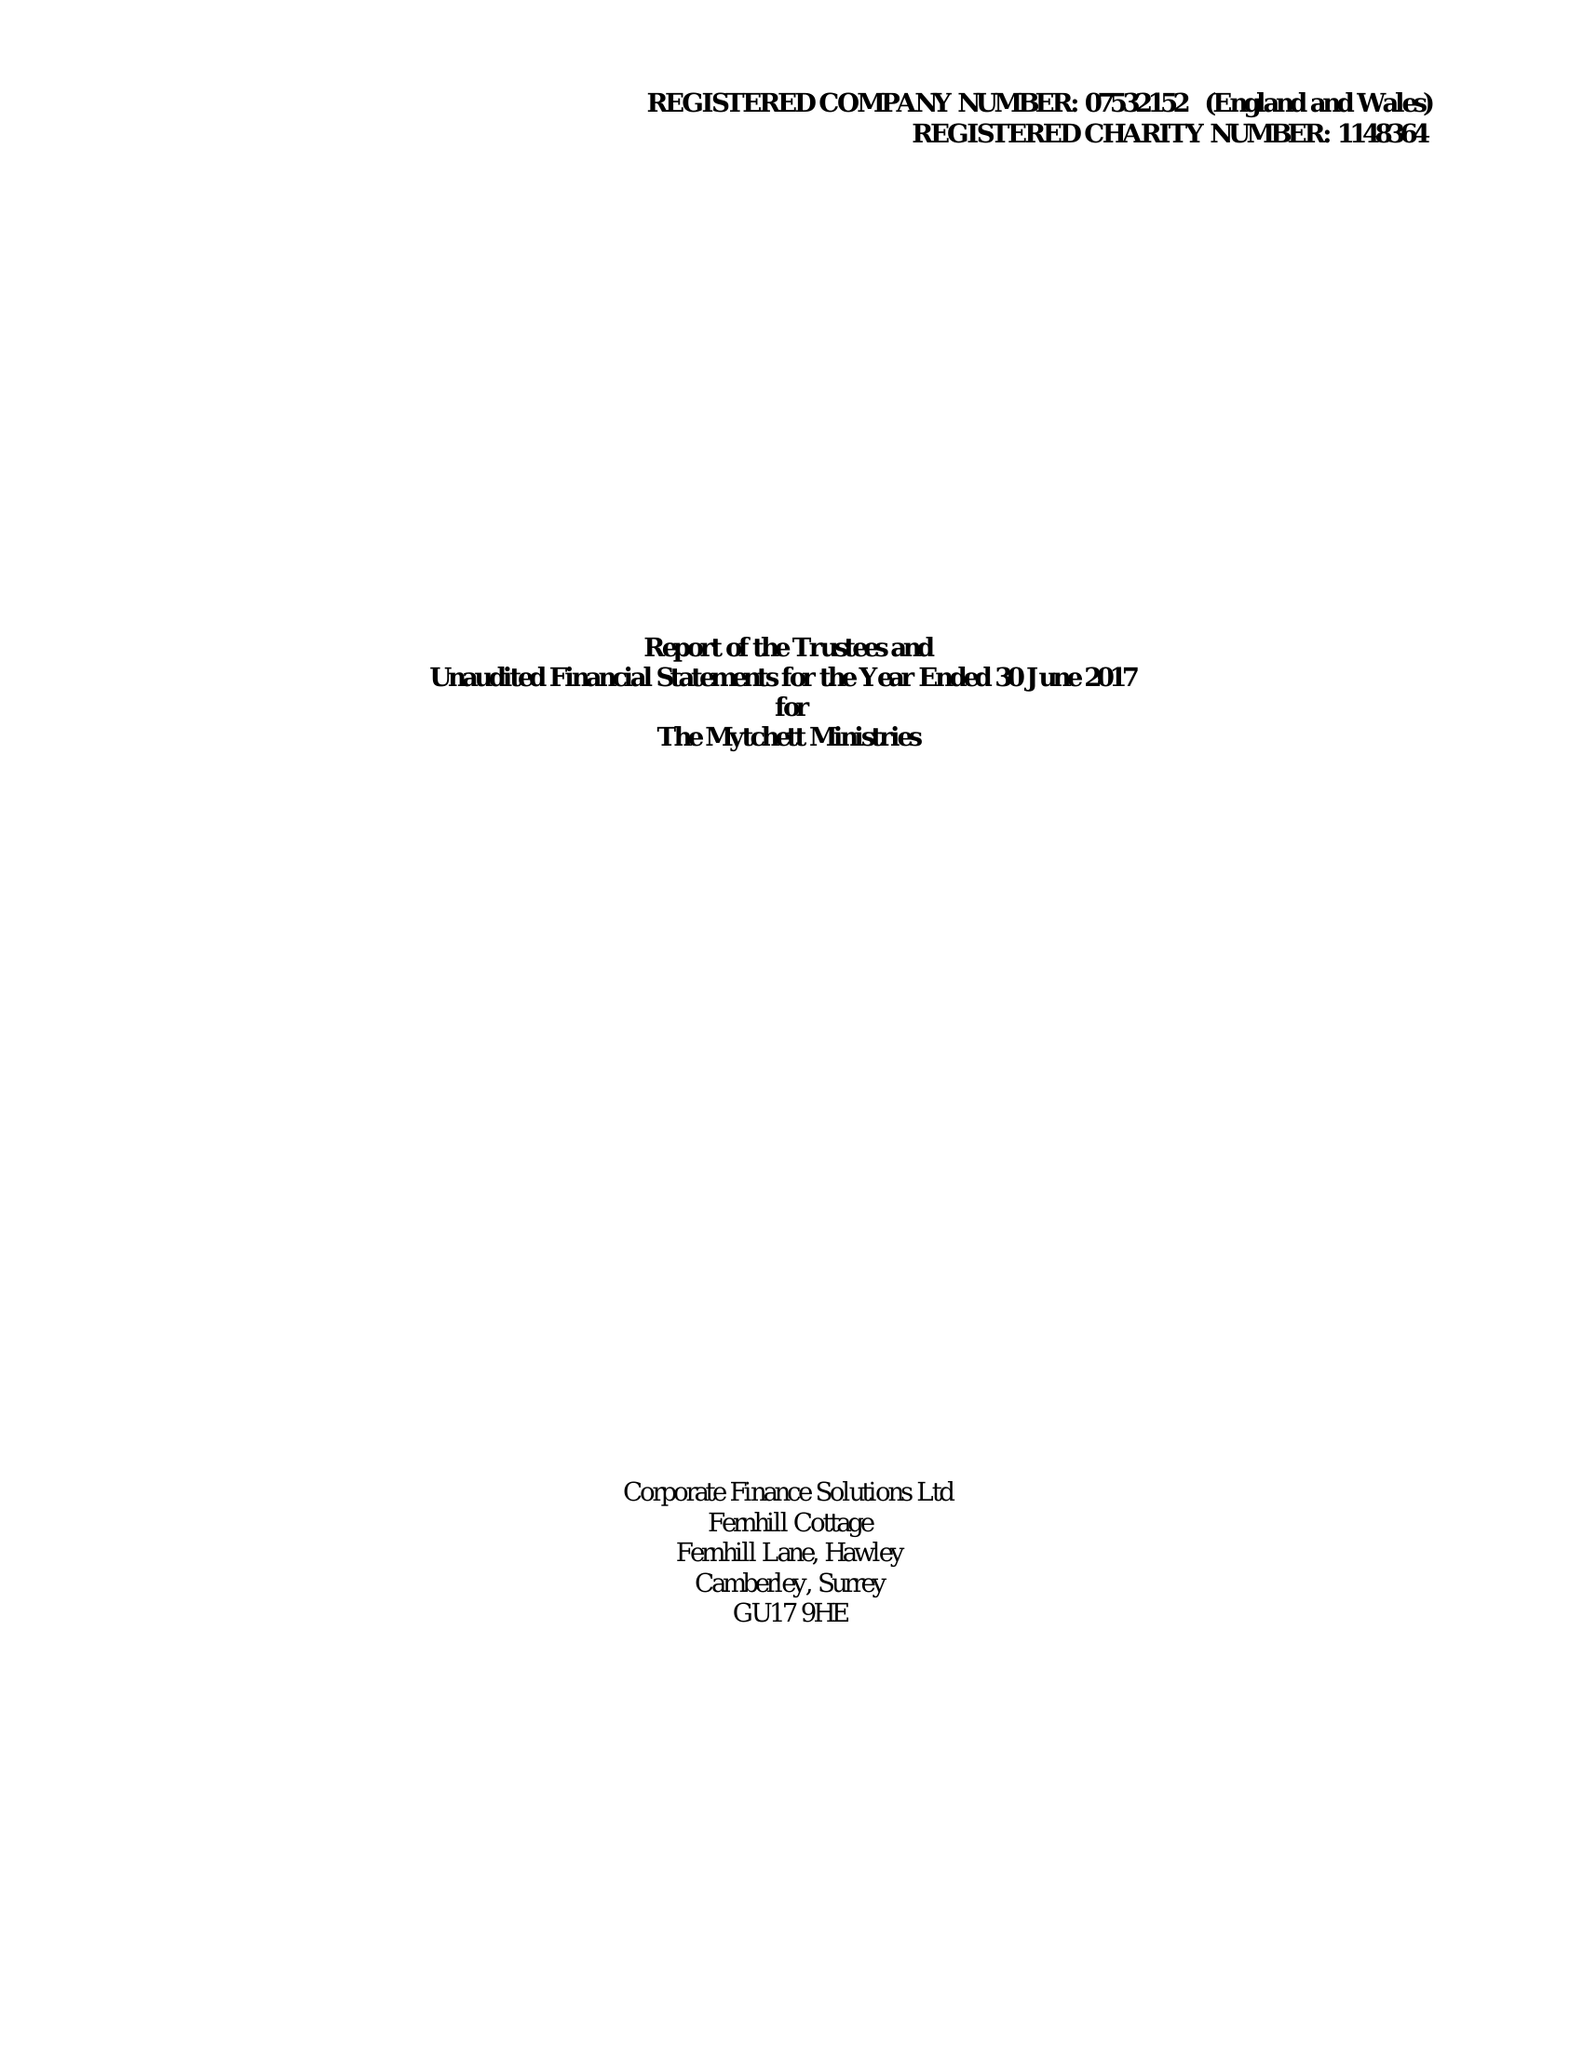What is the value for the address__street_line?
Answer the question using a single word or phrase. MYTCHETT ROAD 